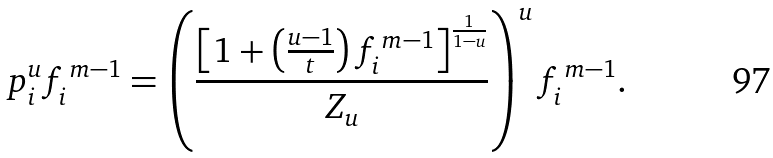Convert formula to latex. <formula><loc_0><loc_0><loc_500><loc_500>p ^ { u } _ { i } f ^ { \, m - 1 } _ { i } = \left ( \frac { \left [ 1 + \left ( \frac { u - 1 } { t } \right ) f ^ { \, m - 1 } _ { i } \right ] ^ { \frac { 1 } { 1 - u } } } { Z _ { u } } \right ) ^ { u } f ^ { \, m - 1 } _ { i } .</formula> 